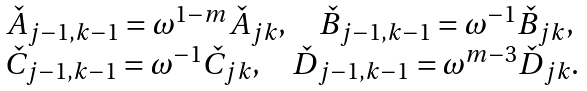Convert formula to latex. <formula><loc_0><loc_0><loc_500><loc_500>\begin{array} { l } \check { A } _ { j - 1 , k - 1 } = \omega ^ { 1 - m } \check { A } _ { j k } , \quad \check { B } _ { j - 1 , k - 1 } = \omega ^ { - 1 } \check { B } _ { j k } , \\ \check { C } _ { j - 1 , k - 1 } = \omega ^ { - 1 } \check { C } _ { j k } , \quad \check { D } _ { j - 1 , k - 1 } = \omega ^ { m - 3 } \check { D } _ { j k } . \end{array}</formula> 